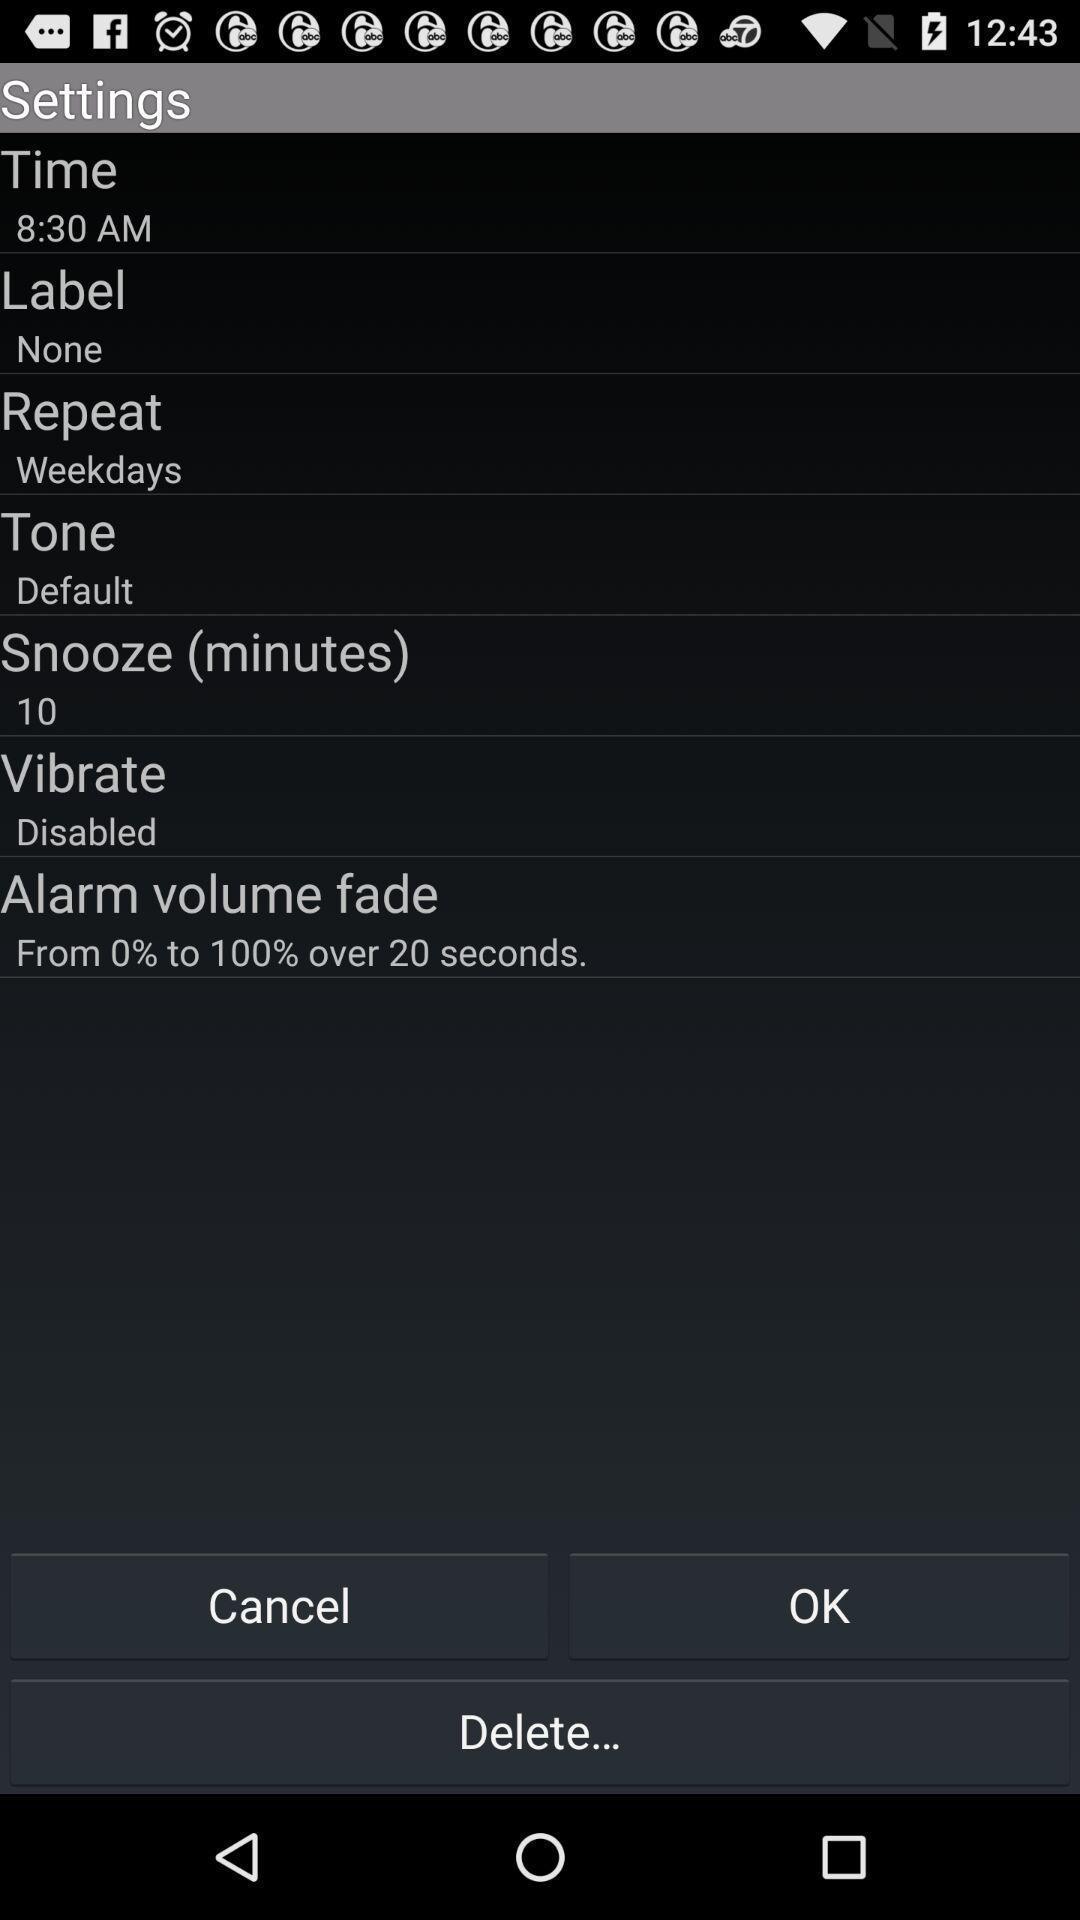Explain what's happening in this screen capture. Settings page with options. 